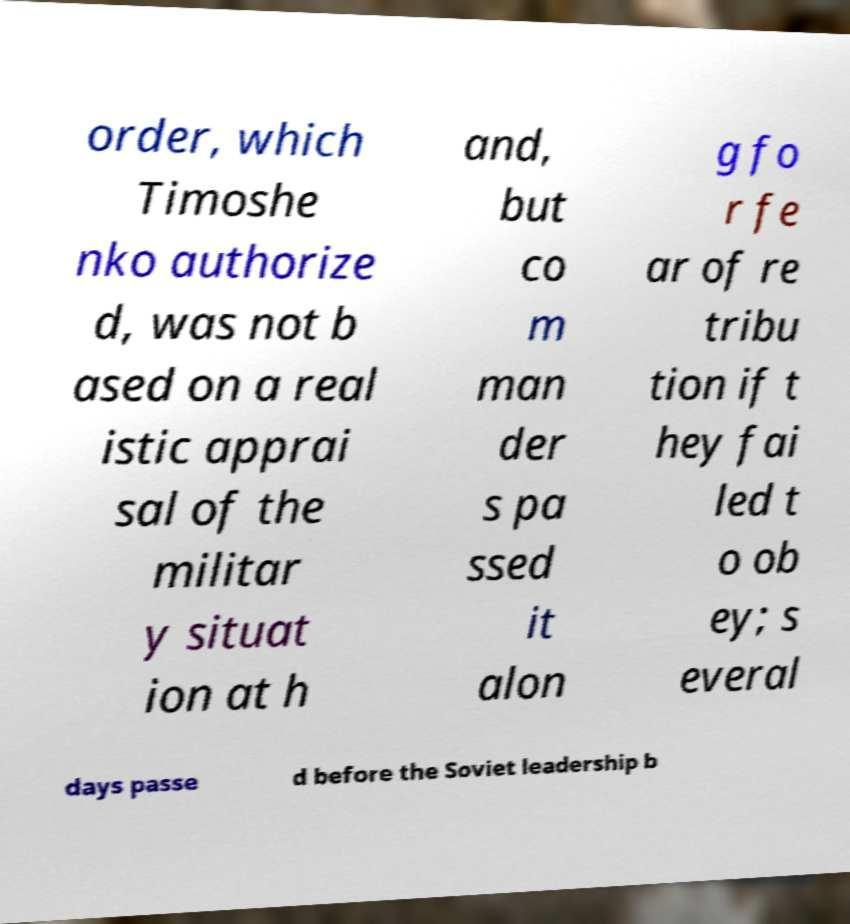Please read and relay the text visible in this image. What does it say? order, which Timoshe nko authorize d, was not b ased on a real istic apprai sal of the militar y situat ion at h and, but co m man der s pa ssed it alon g fo r fe ar of re tribu tion if t hey fai led t o ob ey; s everal days passe d before the Soviet leadership b 